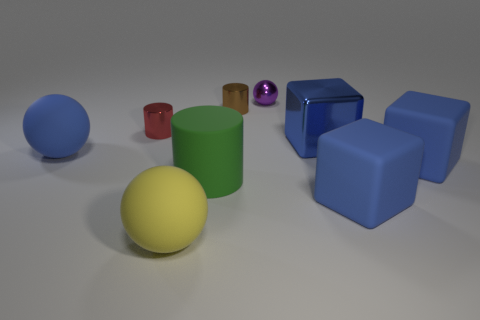The purple metal object that is the same size as the red thing is what shape?
Keep it short and to the point. Sphere. How many other objects are the same color as the matte cylinder?
Your answer should be very brief. 0. What is the tiny purple object made of?
Provide a succinct answer. Metal. How many other objects are the same material as the big green thing?
Offer a very short reply. 4. What size is the metallic object that is in front of the metallic ball and right of the brown metallic cylinder?
Provide a short and direct response. Large. The blue matte object left of the large rubber ball in front of the blue sphere is what shape?
Give a very brief answer. Sphere. Is there any other thing that has the same shape as the red object?
Give a very brief answer. Yes. Are there the same number of yellow balls in front of the small purple ball and tiny brown cylinders?
Keep it short and to the point. Yes. Is the color of the small ball the same as the cylinder that is in front of the blue metal thing?
Your answer should be very brief. No. The shiny thing that is in front of the brown thing and to the right of the big green matte cylinder is what color?
Make the answer very short. Blue. 